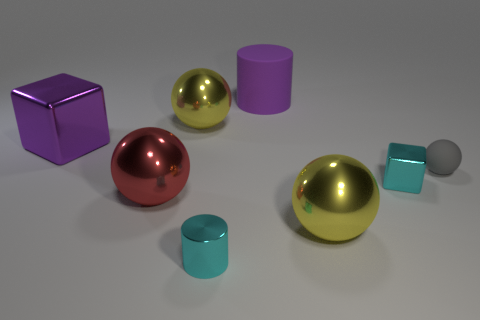There is a block that is in front of the gray thing; is it the same color as the metal cylinder?
Your response must be concise. Yes. Are there any large metallic things that have the same color as the large rubber cylinder?
Ensure brevity in your answer.  Yes. Is the big shiny block the same color as the large cylinder?
Provide a short and direct response. Yes. How big is the sphere that is right of the tiny cyan cylinder and behind the red metallic thing?
Provide a short and direct response. Small. There is a big cube that is the same material as the cyan cylinder; what color is it?
Offer a terse response. Purple. What number of gray spheres have the same material as the tiny cylinder?
Ensure brevity in your answer.  0. Are there the same number of big red shiny balls that are behind the cyan metal cube and big red spheres that are on the left side of the red shiny sphere?
Your response must be concise. Yes. Is the shape of the big red object the same as the yellow object that is to the left of the shiny cylinder?
Your response must be concise. Yes. There is a tiny cube that is the same color as the tiny cylinder; what is its material?
Your response must be concise. Metal. Are the tiny gray sphere and the big purple object that is to the right of the metal cylinder made of the same material?
Provide a succinct answer. Yes. 